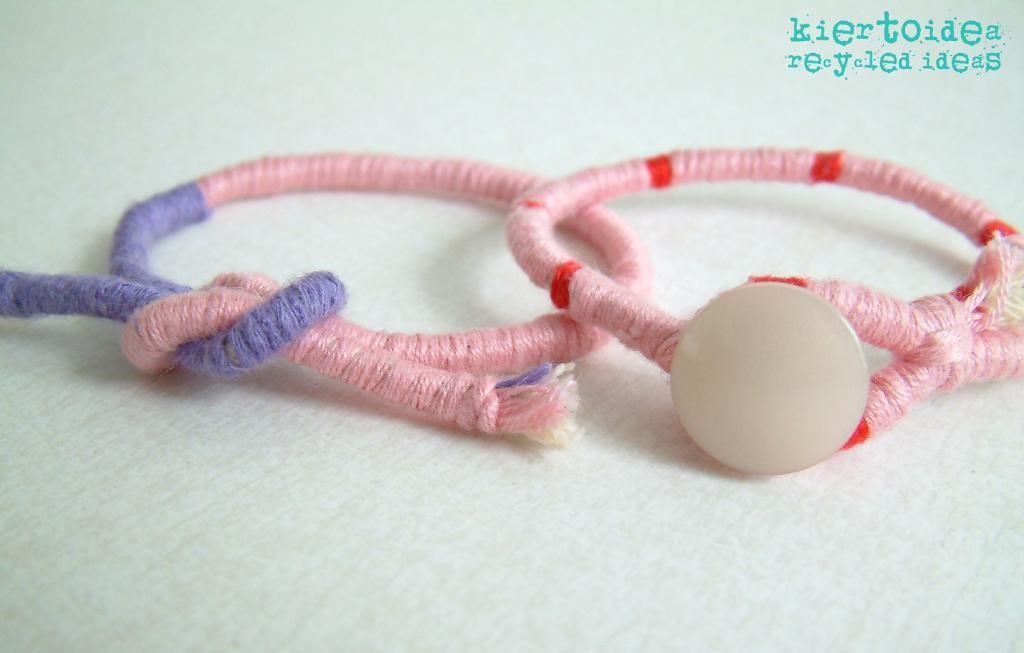What is the main subject of the image? The main subject of the image is two thread rings in the center. Can you describe the text at the top of the image? There is some text at the top of the image, but without more context, it's difficult to provide specific details about the text. What type of ship can be seen sailing in the territory depicted in the image? There is no ship or territory present in the image; it only features two thread rings and some text. 